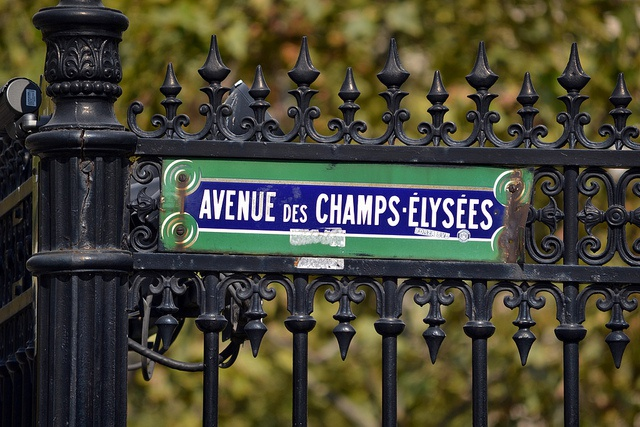Describe the objects in this image and their specific colors. I can see various objects in this image with different colors. 